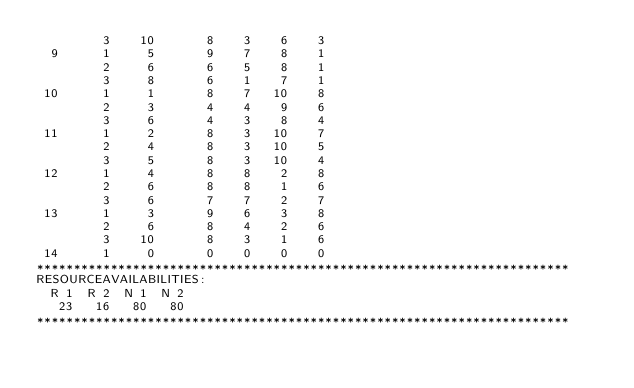Convert code to text. <code><loc_0><loc_0><loc_500><loc_500><_ObjectiveC_>         3    10       8    3    6    3
  9      1     5       9    7    8    1
         2     6       6    5    8    1
         3     8       6    1    7    1
 10      1     1       8    7   10    8
         2     3       4    4    9    6
         3     6       4    3    8    4
 11      1     2       8    3   10    7
         2     4       8    3   10    5
         3     5       8    3   10    4
 12      1     4       8    8    2    8
         2     6       8    8    1    6
         3     6       7    7    2    7
 13      1     3       9    6    3    8
         2     6       8    4    2    6
         3    10       8    3    1    6
 14      1     0       0    0    0    0
************************************************************************
RESOURCEAVAILABILITIES:
  R 1  R 2  N 1  N 2
   23   16   80   80
************************************************************************
</code> 